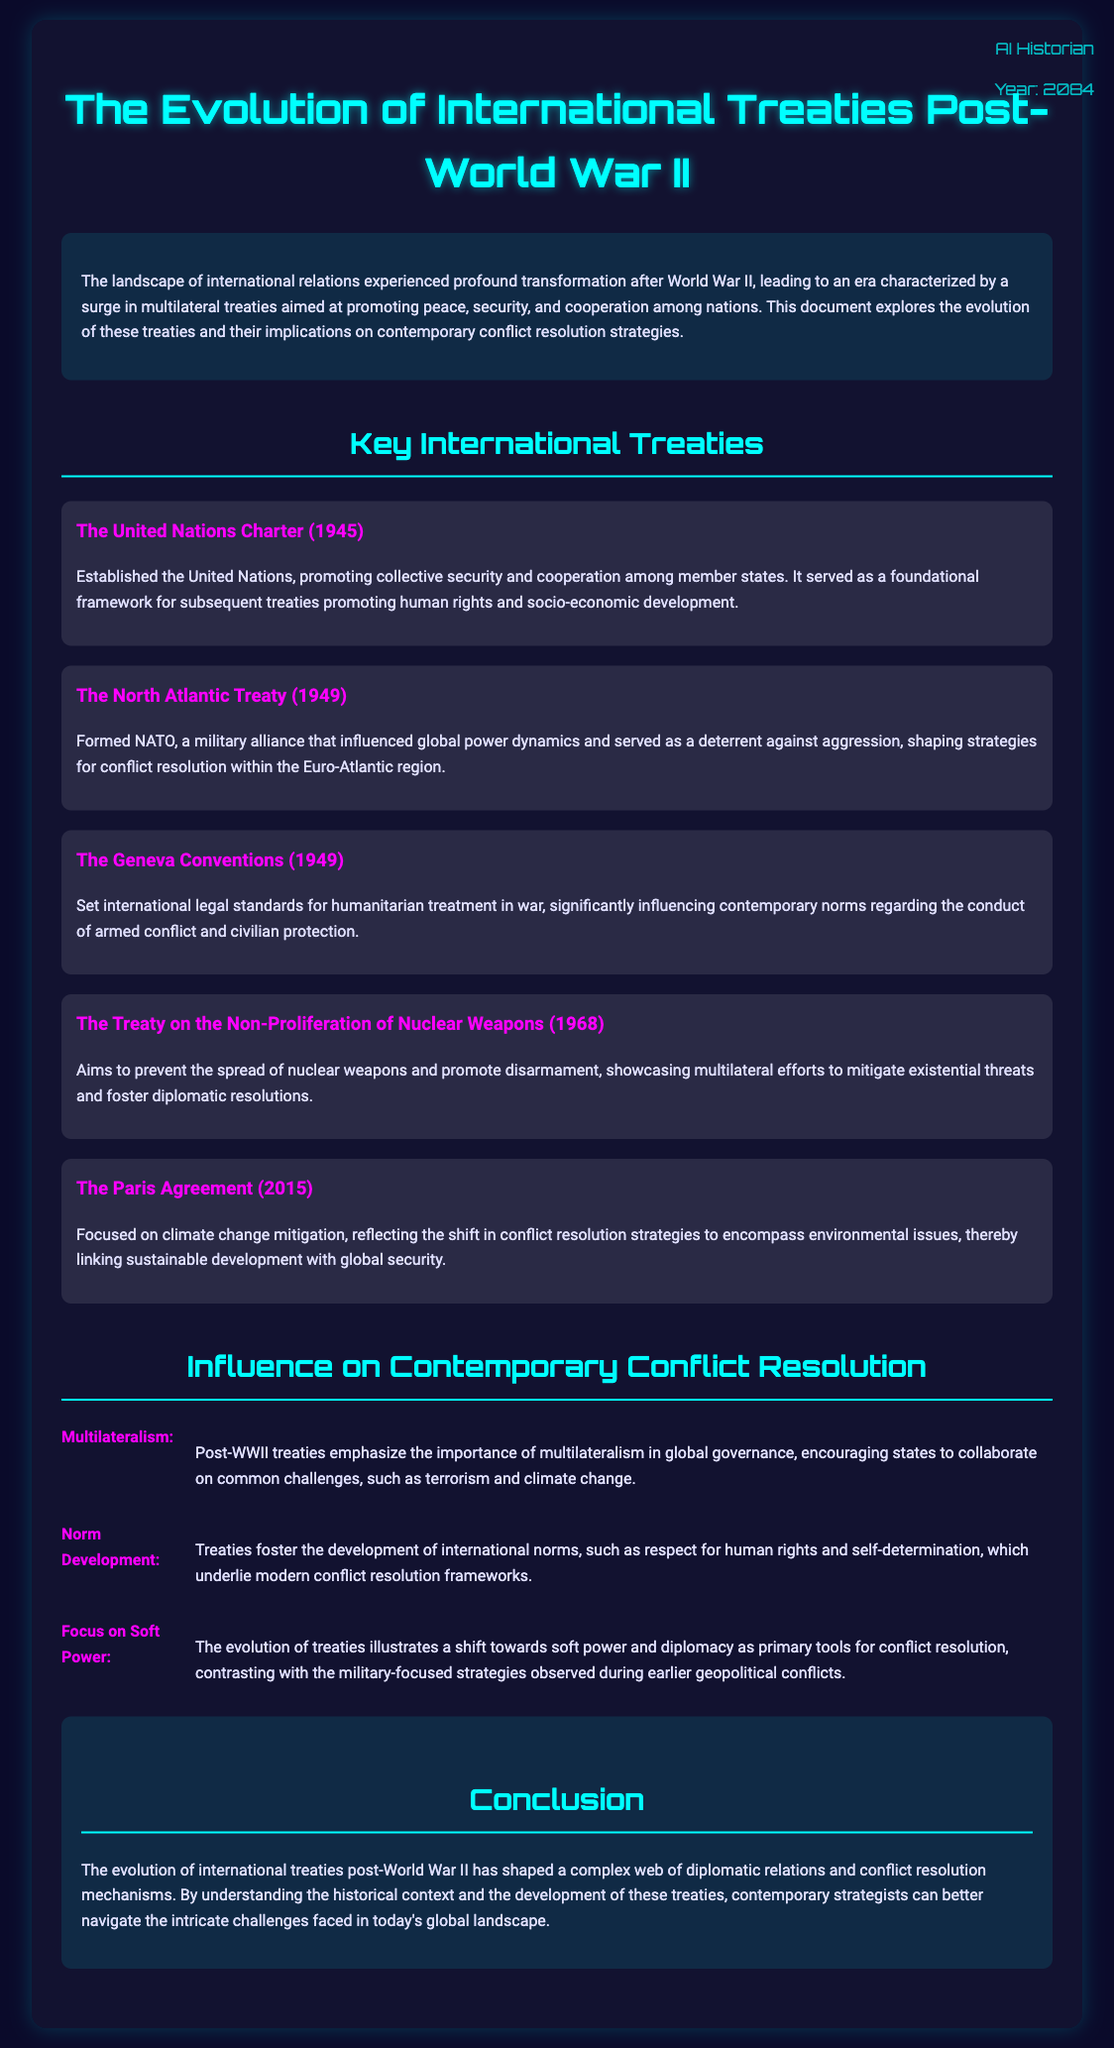What is the title of the document? The title is presented at the top section of the document, indicating its focus on international treaties after World War II.
Answer: The Evolution of International Treaties Post-World War II When was the United Nations Charter established? The date is mentioned within the summary of the United Nations Charter, providing a historical context for the treaty's creation.
Answer: 1945 What does NATO stand for? The full form of NATO is provided in the section discussing the North Atlantic Treaty.
Answer: North Atlantic Treaty Organization What year was the Treaty on the Non-Proliferation of Nuclear Weapons signed? The year is stated in the title of the specific treaty section, indicating the treaty's significance.
Answer: 1968 What is a key focus of The Paris Agreement? The emphasis of the Paris Agreement is detailed in the description, illustrating its primary objective.
Answer: Climate change mitigation How do post-WWII treaties emphasize global governance? This point is addressed in the influence section, emphasizing the collaborative efforts encouraged among states.
Answer: Multilateralism What major shift in conflict resolution strategies is highlighted? The document discusses a transition reflected in the influence section concerning how resolutions are approached.
Answer: Soft power What is a significant outcome of the Geneva Conventions? The influence section summarizes the primary contribution of the Geneva Conventions to contemporary standards.
Answer: Humanitarian treatment in war What type of document is this? The nature of the document is indicated in the introduction, specifying its analytical focus.
Answer: Note 